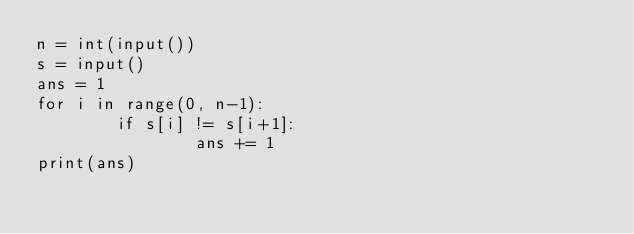Convert code to text. <code><loc_0><loc_0><loc_500><loc_500><_Python_>n = int(input())
s = input()
ans = 1
for i in range(0, n-1):
        if s[i] != s[i+1]:
                ans += 1
print(ans)</code> 